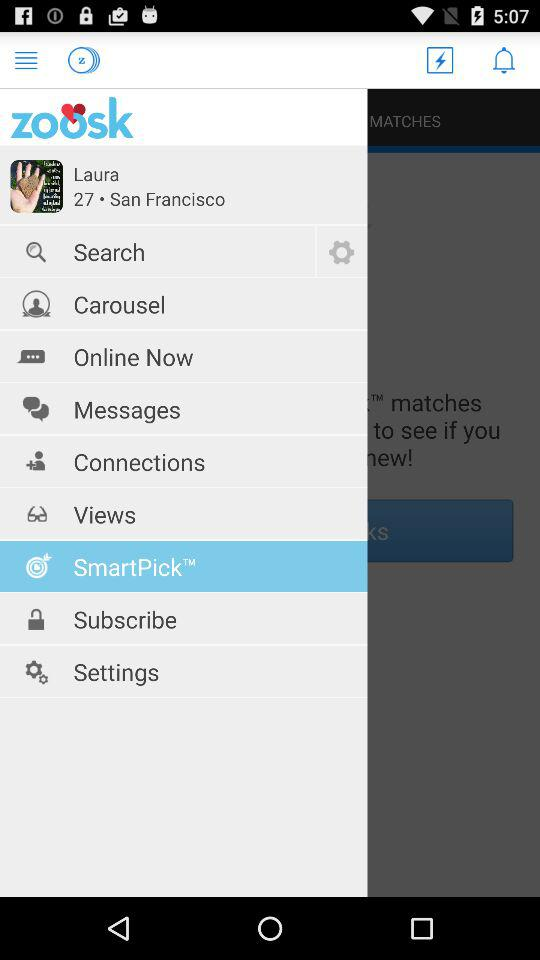What is the location of the user? The location of the user is San Francisco. 